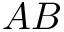Convert formula to latex. <formula><loc_0><loc_0><loc_500><loc_500>A B</formula> 